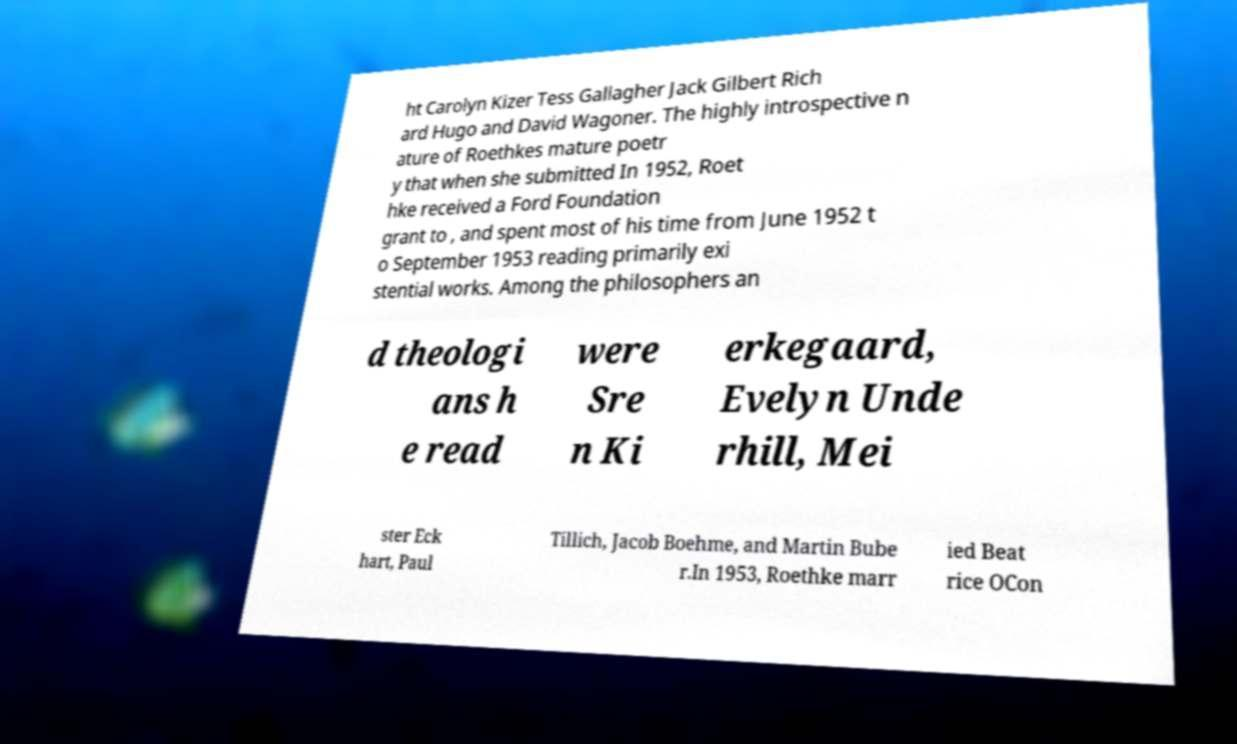Can you accurately transcribe the text from the provided image for me? ht Carolyn Kizer Tess Gallagher Jack Gilbert Rich ard Hugo and David Wagoner. The highly introspective n ature of Roethkes mature poetr y that when she submitted In 1952, Roet hke received a Ford Foundation grant to , and spent most of his time from June 1952 t o September 1953 reading primarily exi stential works. Among the philosophers an d theologi ans h e read were Sre n Ki erkegaard, Evelyn Unde rhill, Mei ster Eck hart, Paul Tillich, Jacob Boehme, and Martin Bube r.In 1953, Roethke marr ied Beat rice OCon 